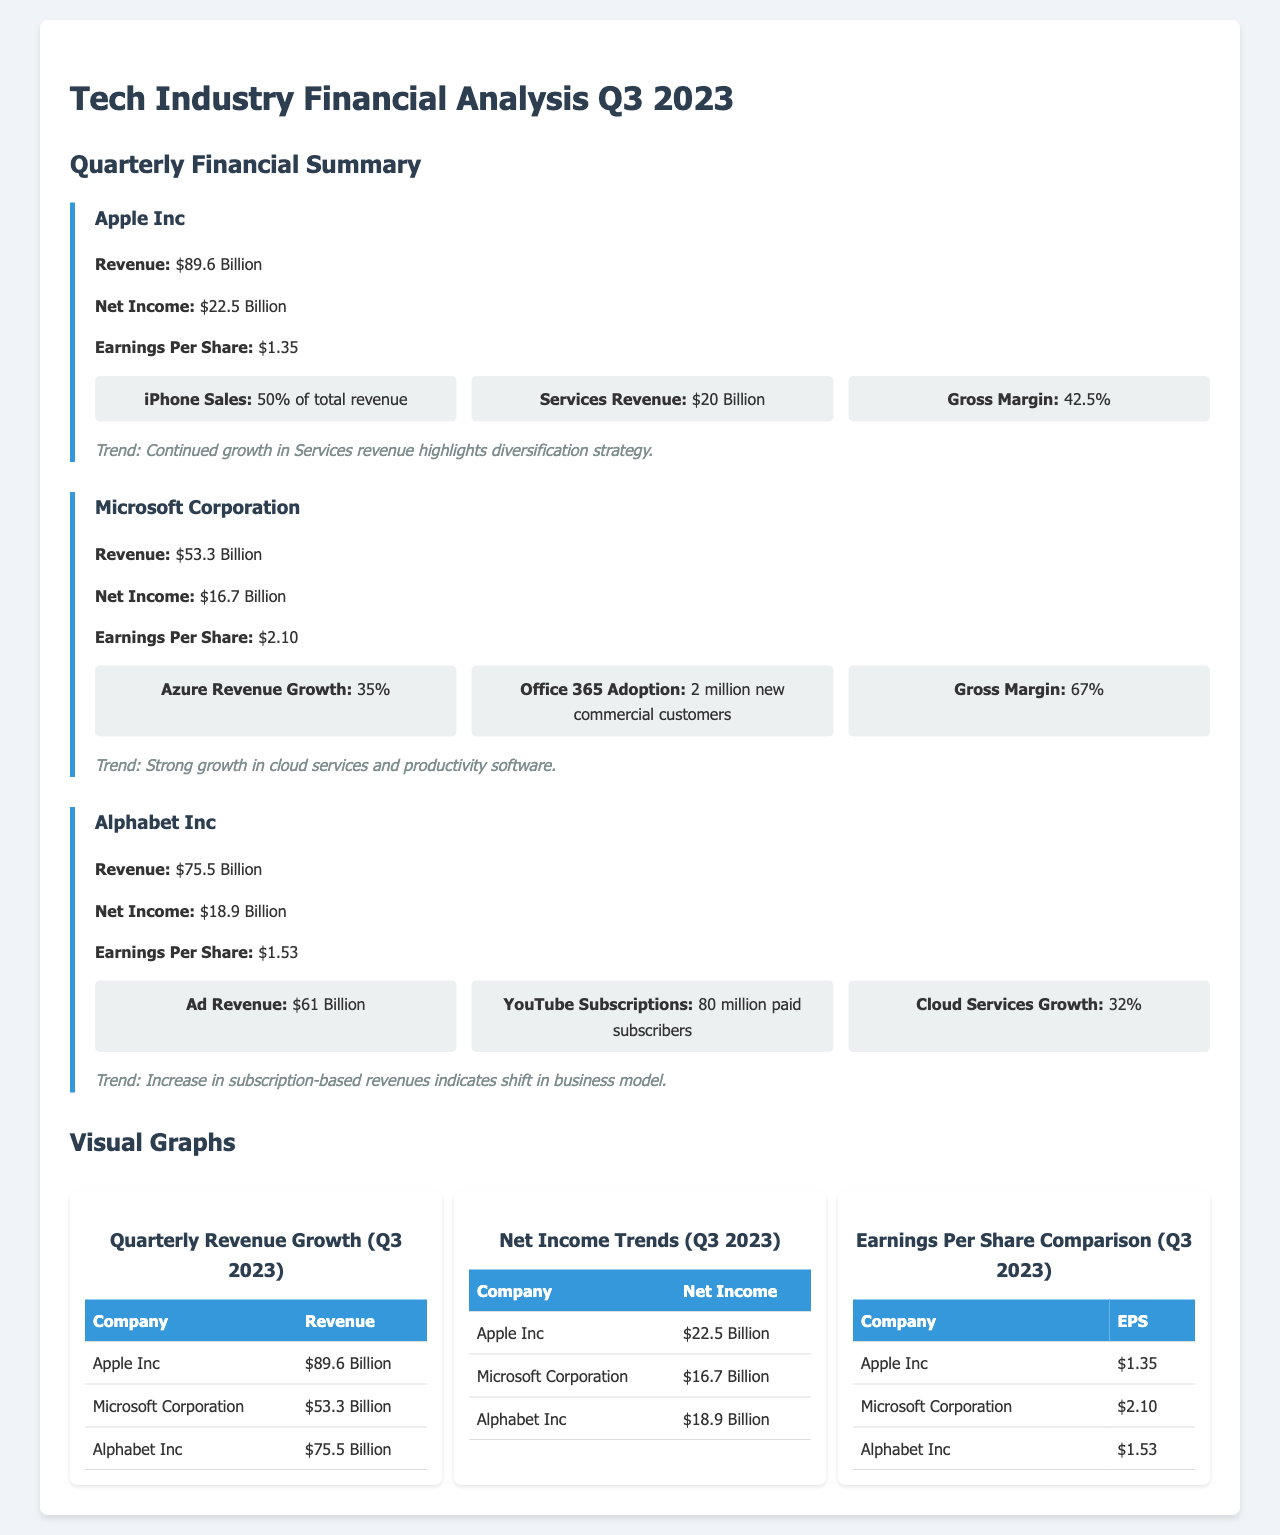What was Apple's revenue in Q3 2023? The document states Apple's revenue as $89.6 Billion.
Answer: $89.6 Billion What is Microsoft Corporation's net income? The net income for Microsoft Corporation listed in the document is $16.7 Billion.
Answer: $16.7 Billion How much did Alphabet Inc earn per share? The earnings per share for Alphabet Inc is reported as $1.53 in the document.
Answer: $1.53 What percentage of total revenue comes from iPhone sales for Apple? The document indicates that iPhone sales represent 50% of total revenue for Apple.
Answer: 50% What trend is highlighted for Microsoft Corporation? The document highlights strong growth in cloud services and productivity software as a trend for Microsoft Corporation.
Answer: Strong growth in cloud services and productivity software Which company had the highest gross margin? According to the document, Microsoft Corporation had the highest gross margin at 67%.
Answer: 67% How many new commercial customers did Microsoft gain for Office 365? The document states that Microsoft gained 2 million new commercial customers for Office 365.
Answer: 2 million What is the gross margin reported for Apple Inc? The gross margin reported for Apple Inc in the document is 42.5%.
Answer: 42.5% What indicates a shift in Alphabet Inc's business model? The document notes that an increase in subscription-based revenues indicates a shift in Alphabet Inc's business model.
Answer: Increase in subscription-based revenues 